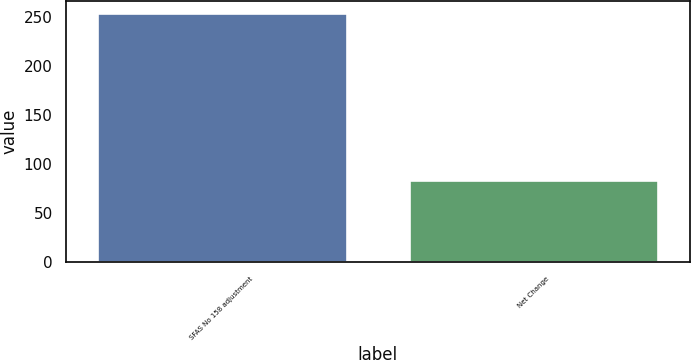Convert chart to OTSL. <chart><loc_0><loc_0><loc_500><loc_500><bar_chart><fcel>SFAS No 158 adjustment<fcel>Net Change<nl><fcel>254<fcel>84<nl></chart> 